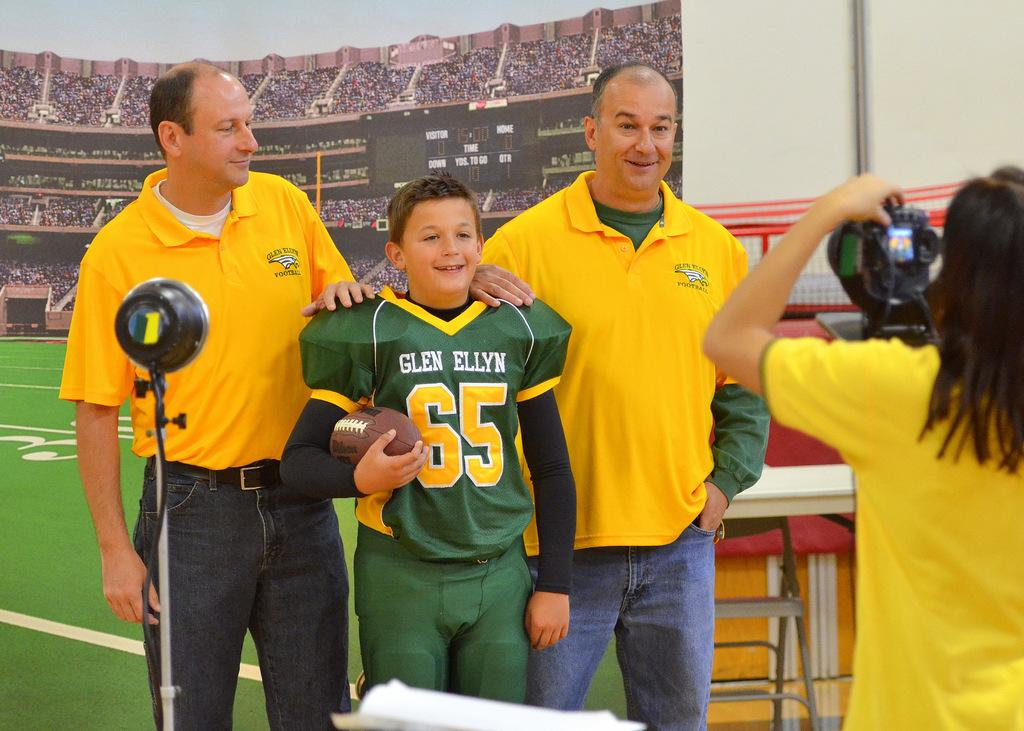Provide a one-sentence caption for the provided image. Number 65 for the Glen Ellyn football team poses with two men. 